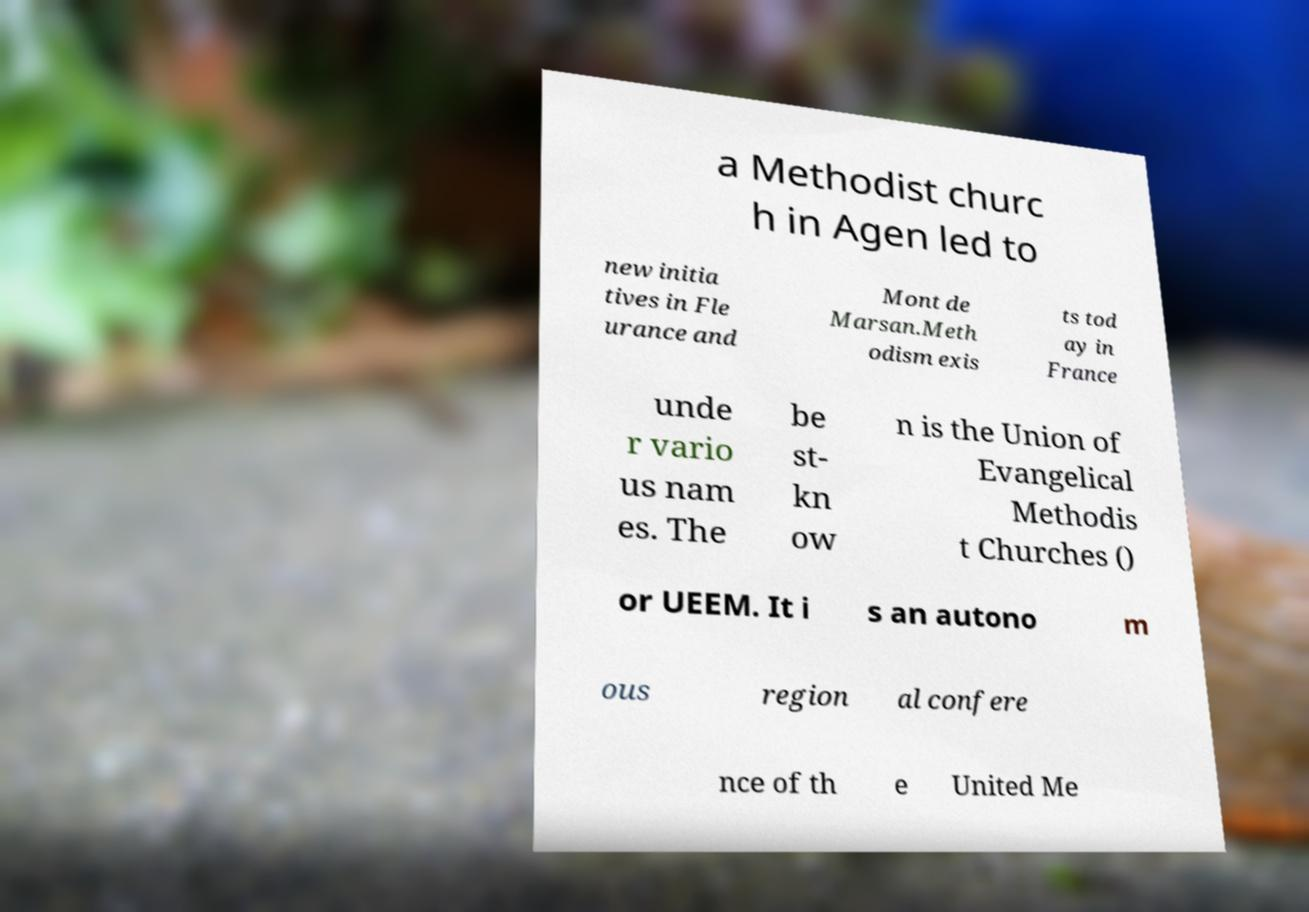I need the written content from this picture converted into text. Can you do that? a Methodist churc h in Agen led to new initia tives in Fle urance and Mont de Marsan.Meth odism exis ts tod ay in France unde r vario us nam es. The be st- kn ow n is the Union of Evangelical Methodis t Churches () or UEEM. It i s an autono m ous region al confere nce of th e United Me 